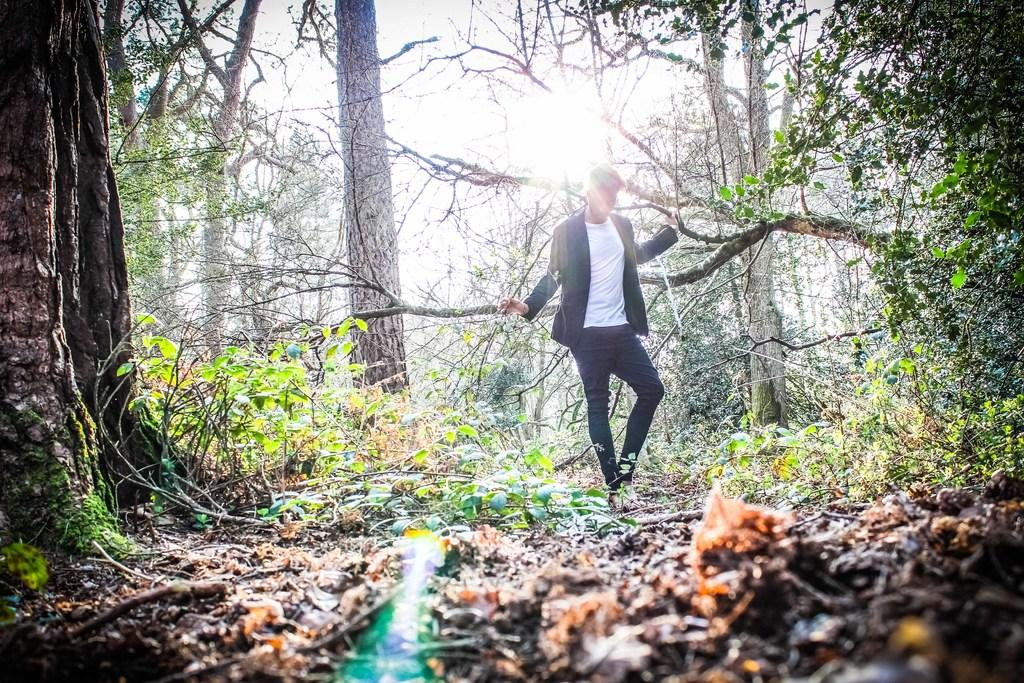What is the main subject of the image? There is a person standing in the image. What type of vegetation can be seen in the image? There are plants and trees in the image. What is visible at the top of the image? The sky is visible at the top of the image. What type of snake can be seen slithering through the plants in the image? There is no snake present in the image; it only features a person, plants, trees, and the sky. Who is the writer of the book that the person is holding in the image? There is no book or writer mentioned in the image; it only shows a person standing amidst plants, trees, and the sky. 